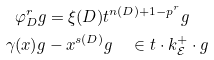<formula> <loc_0><loc_0><loc_500><loc_500>\varphi _ { D } ^ { r } g & = \xi ( { D } ) t ^ { n ( { D } ) + 1 - p ^ { r } } g \\ \gamma ( x ) g & - x ^ { s ( { D } ) } g \quad \in t \cdot k ^ { + } _ { \mathcal { E } } \cdot g</formula> 